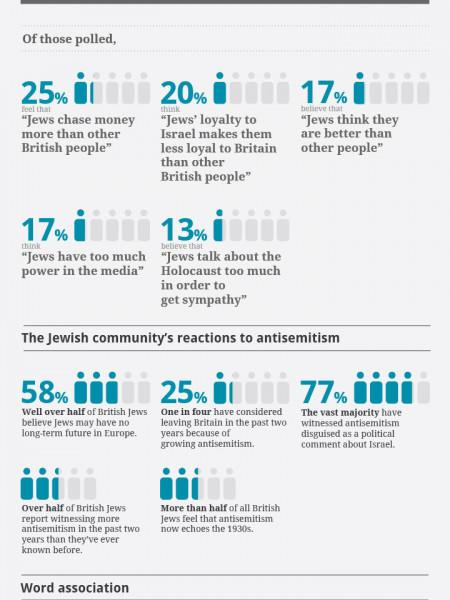Identify some key points in this picture. A recent survey revealed that approximately 25% of Jews in Britain have considered leaving the country in the past two years due to rising levels of anti-Semitism. A staggering 17% of individuals believe that Jews have too much power in the media, according to a recent survey. The loyalty of Jews to their country, Britain, is being questioned in this text. According to the data, 17% of the respondents believe that Jews are better than other people. According to a recent survey, 58% of people believe that Jews do not have a long-term future in Europe. 